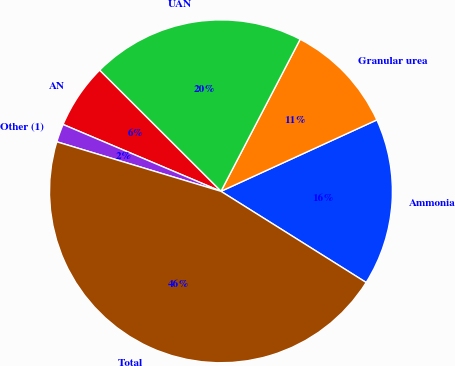Convert chart. <chart><loc_0><loc_0><loc_500><loc_500><pie_chart><fcel>Ammonia<fcel>Granular urea<fcel>UAN<fcel>AN<fcel>Other (1)<fcel>Total<nl><fcel>15.76%<fcel>10.52%<fcel>20.16%<fcel>6.11%<fcel>1.71%<fcel>45.74%<nl></chart> 